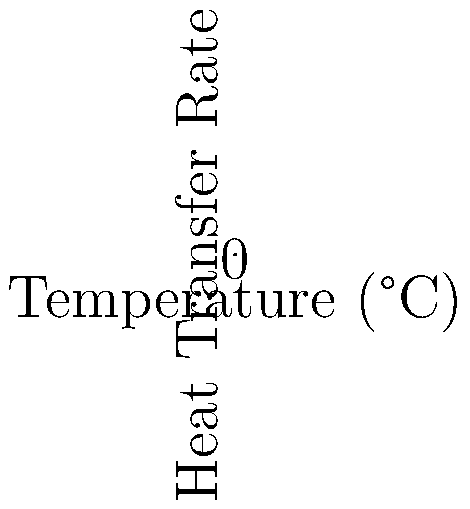The graph shows heat transfer rates for three traditional cooking methods from different cultures. Which method exhibits the highest heat transfer rate at higher temperatures, and how does this relate to its cultural significance and cooking efficiency? To answer this question, we need to analyze the graph and consider the cultural context:

1. Identify the curves:
   - Blue curve: Clay pot (common in various cultures)
   - Red curve: Wok (East Asian cooking)
   - Green curve: Tandoor (South Asian cooking)

2. Analyze the heat transfer rates:
   - At lower temperatures, the clay pot has the highest heat transfer rate.
   - As temperature increases, the wok's heat transfer rate increases more rapidly.
   - At the highest temperatures, the tandoor shows the steepest curve and highest heat transfer rate.

3. Mathematical analysis:
   Let $Q$ be the heat transfer rate and $T$ be the temperature.
   The curves approximately follow the form $Q = kT^n$, where $k$ is a constant and $n$ is the power.
   - Clay pot: $Q \approx 0.5T^{1.25}$
   - Wok: $Q \approx 0.3T^{1.5}$
   - Tandoor: $Q \approx 0.2T^{1.75}$

   The tandoor has the highest exponent, explaining its dominance at high temperatures.

4. Cultural significance and efficiency:
   - Tandoor ovens are designed for high-temperature cooking, often reaching 480°C (900°F).
   - This high heat transfer rate allows for quick cooking of breads (naan) and meats.
   - The efficiency of the tandoor reflects the need for fuel conservation in its regions of origin.
   - Its design has evolved to maximize heat utilization, showing how cultural practices adapt to environmental constraints.

5. Postcolonial perspective:
   - The superiority of the tandoor at high temperatures challenges Eurocentric assumptions about cooking technology.
   - This graph demonstrates how indigenous knowledge systems have developed highly efficient cooking methods, often overlooked in Western-centric narratives of technological progress.
Answer: Tandoor; highest heat transfer at high temperatures reflects cultural adaptation to maximize cooking efficiency and fuel conservation. 